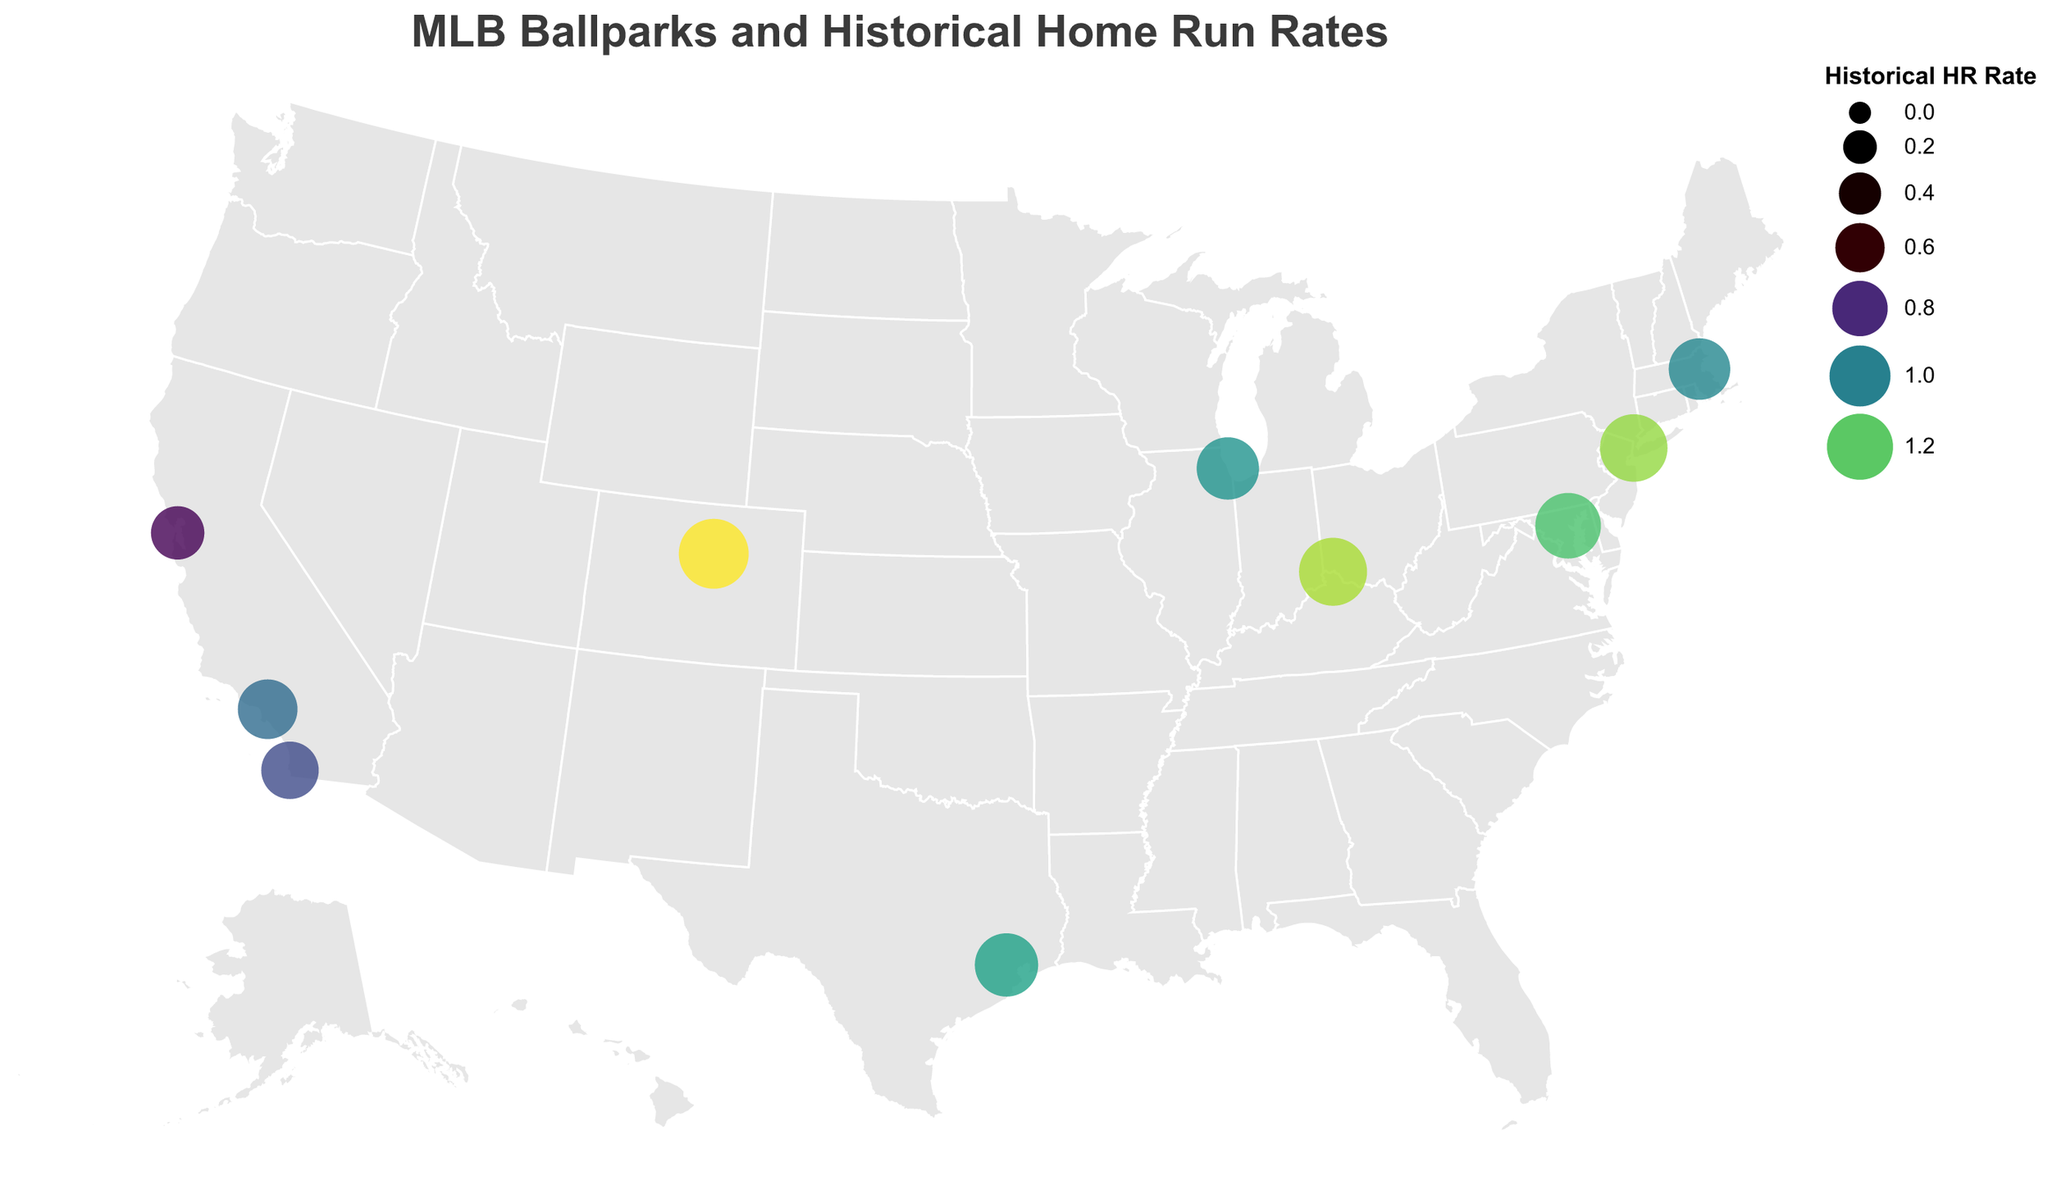What's the title of the figure? The title is displayed at the top of the figure in larger font, which reads "MLB Ballparks and Historical Home Run Rates."
Answer: MLB Ballparks and Historical Home Run Rates How many ballparks are shown in the figure? By counting the number of data points (circles) displayed on the map, we can conclude there are 10 ballparks.
Answer: 10 Which ballpark has the highest Historical HR Rate? By examining the size and color of the circles, Coors Field in Denver, CO has the largest circle and the deepest color, indicating the highest Historical HR Rate of 1.36.
Answer: Coors Field What is the latitude and longitude of Fenway Park? By referring to the tooltip on the circle associated with Fenway Park, it shows the latitude of 42.3467 and the longitude of -71.0972 for Fenway Park in Boston, MA.
Answer: 42.3467, -71.0972 Which two ballparks are located in California and how do their HR rates compare? By identifying the ballparks in California, we have Dodger Stadium in Los Angeles and Oracle Park in San Francisco. Dodger Stadium has a HR rate of 0.95, while Oracle Park has a HR rate of 0.73, indicating Dodger Stadium has a higher HR rate.
Answer: Dodger Stadium has a higher HR rate than Oracle Park Which ballpark is located furthest east? By looking at the longitude coordinates of each ballpark, the one with the smallest (most negative) longitude is Yankee Stadium in New York, NY at -73.9262.
Answer: Yankee Stadium What's the average Historical HR Rate of all ballparks shown? Sum all the HR rates (1.02 + 1.05 + 1.26 + 0.95 + 0.73 + 1.36 + 1.18 + 1.28 + 1.09 + 0.87) to get 10.79. Divide by the number of ballparks (10), yielding an average HR rate of 1.079.
Answer: 1.079 Does Minute Maid Park have a higher HR rate compared to Petco Park? Minute Maid Park in Houston, TX has an HR rate of 1.09, while Petco Park in San Diego, CA has an HR rate of 0.87. Thus, Minute Maid Park has a higher HR rate.
Answer: Yes, Minute Maid Park has a higher HR rate What's the difference in Historical HR Rates between Fenway Park and Great American Ball Park? Fenway Park has a HR rate of 1.02, while Great American Ball Park has a HR rate of 1.28. The difference is calculated as 1.28 - 1.02 = 0.26.
Answer: 0.26 Which state has the most ballparks shown in the figure and how many? By reviewing the states listed for each ballpark, California appears twice (Dodger Stadium and Oracle Park), which is the most for a single state.
Answer: California, 2 